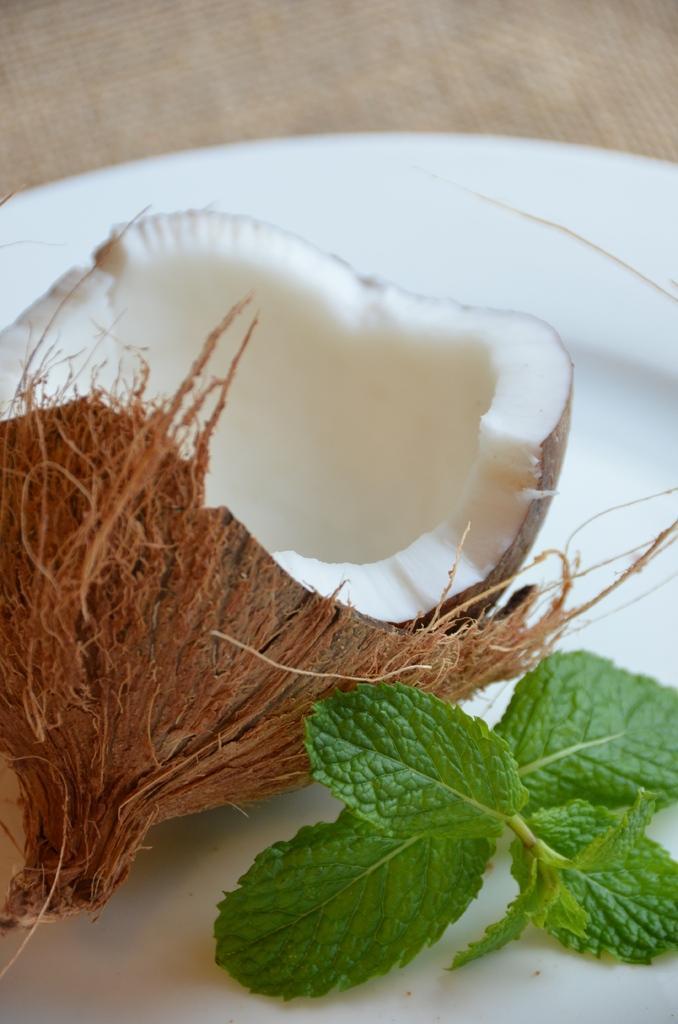In one or two sentences, can you explain what this image depicts? In this image I can see the coconut, mint leaves in the white color plate. Background is in brown color. 